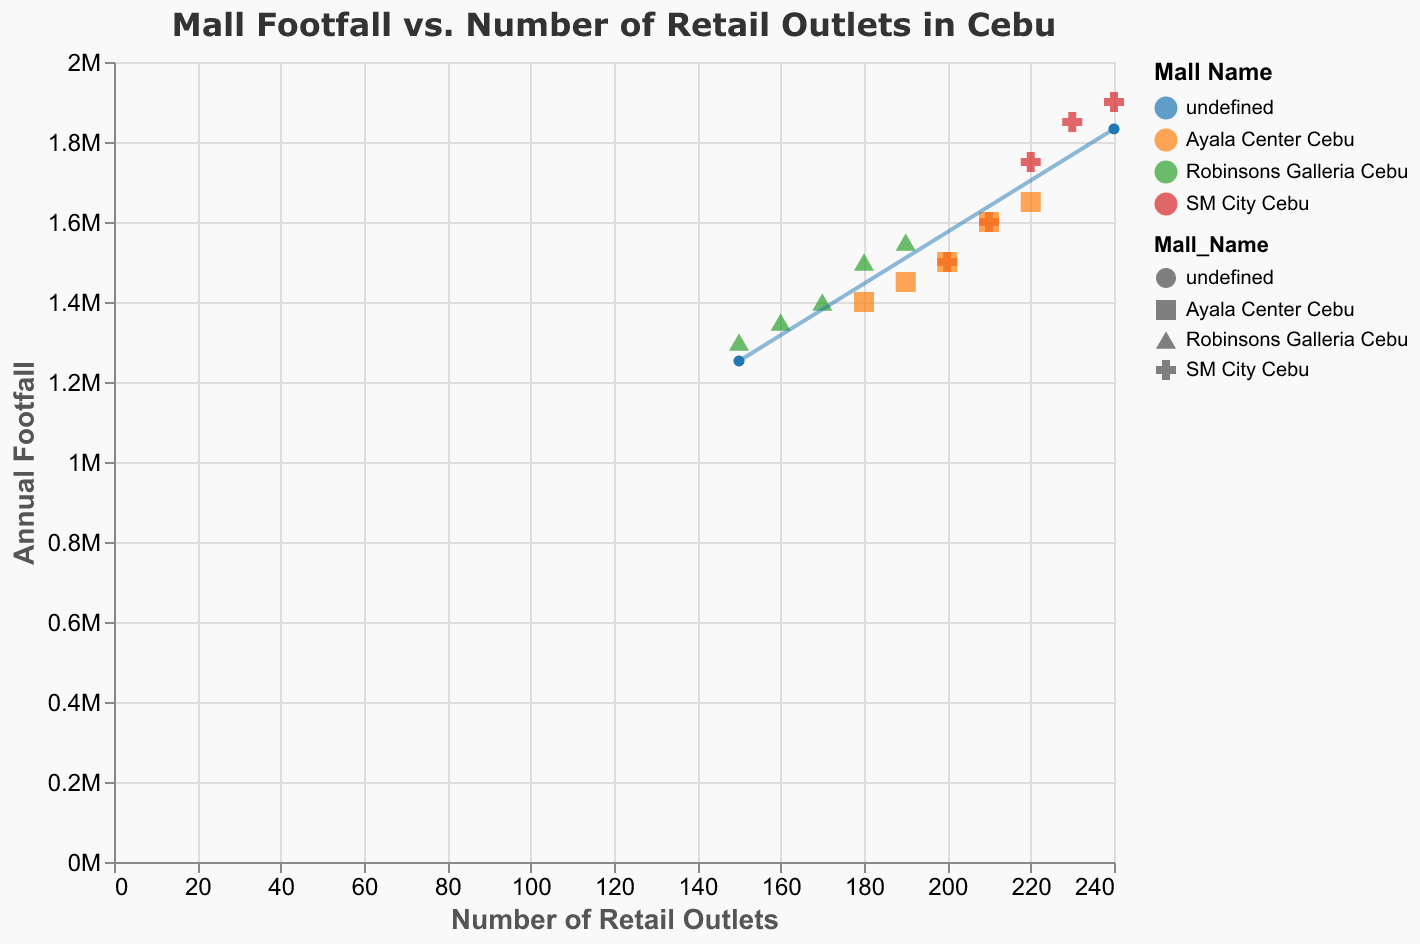What's the title of the figure? The title is displayed at the top of the figure and reads "Mall Footfall vs. Number of Retail Outlets in Cebu"
Answer: Mall Footfall vs. Number of Retail Outlets in Cebu Which mall had the highest footfall in 2019? In 2019, SM City Cebu has a footfall of 1,900,000 which is the highest compared to Ayala Center Cebu (1,650,000) and Robinsons Galleria Cebu (1,550,000).
Answer: SM City Cebu How does the number of retail outlets affect footfall for the malls? By observing the overall trend line and data points, we can see that as the number of retail outlets increases, the footfall generally increases for all malls.
Answer: Increases Compare the number of retail outlets in Ayala Center Cebu and Robinsons Galleria Cebu in 2017. Which one had more? In 2017, Ayala Center Cebu had 200 retail outlets while Robinsons Galleria Cebu had 170 retail outlets.
Answer: Ayala Center Cebu What is the annual footfall for Robinsons Galleria Cebu in 2016? Hovering over the data points or checking the tooltip for Robinsons Galleria Cebu in 2016 shows a footfall of 1,350,000.
Answer: 1,350,000 What can you infer about the trend line in the figure? The trend line indicates a positive correlation between the number of retail outlets and footfall, meaning that as more retail outlets are added, the footfall tends to increase.
Answer: Positive correlation Which mall displayed the least increase in footfall from 2015 to 2019? By comparing the footfall data across the years 2015 to 2019 for each mall, Robinsons Galleria Cebu increased from 1,300,000 to 1,550,000, the smallest increase compared to the other malls.
Answer: Robinsons Galleria Cebu What's the average footfall for SM City Cebu across all years? Adding the footfalls for SM City Cebu from 2015 to 2019 (1,500,000 + 1,600,000 + 1,750,000 + 1,850,000 + 1,900,000) and dividing by 5 gives: (1,500,000 + 1,600,000 + 1,750,000 + 1,850,000 + 1,900,000) / 5 = 1,720,000
Answer: 1,720,000 How many data points are in the figure? Counting all the entries in the data table, which includes 5 years of data for 3 malls, gives 15 data points.
Answer: 15 Which mall had the highest increase in the number of retail outlets from 2015 to 2019? SM City Cebu increased from 200 to 240 retail outlets, the highest increase of 40 outlets compared to Ayala Center Cebu (180 to 220) and Robinsons Galleria Cebu (150 to 190).
Answer: SM City Cebu 